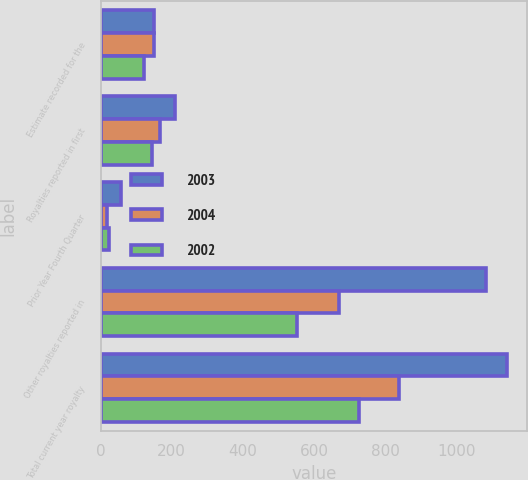Convert chart to OTSL. <chart><loc_0><loc_0><loc_500><loc_500><stacked_bar_chart><ecel><fcel>Estimate recorded for the<fcel>Royalties reported in first<fcel>Prior Year Fourth Quarter<fcel>Other royalties reported in<fcel>Total current year royalty<nl><fcel>2003<fcel>151<fcel>208<fcel>57<fcel>1084<fcel>1141<nl><fcel>2004<fcel>150<fcel>167<fcel>17<fcel>670<fcel>838<nl><fcel>2002<fcel>122<fcel>146<fcel>24<fcel>551<fcel>725<nl></chart> 